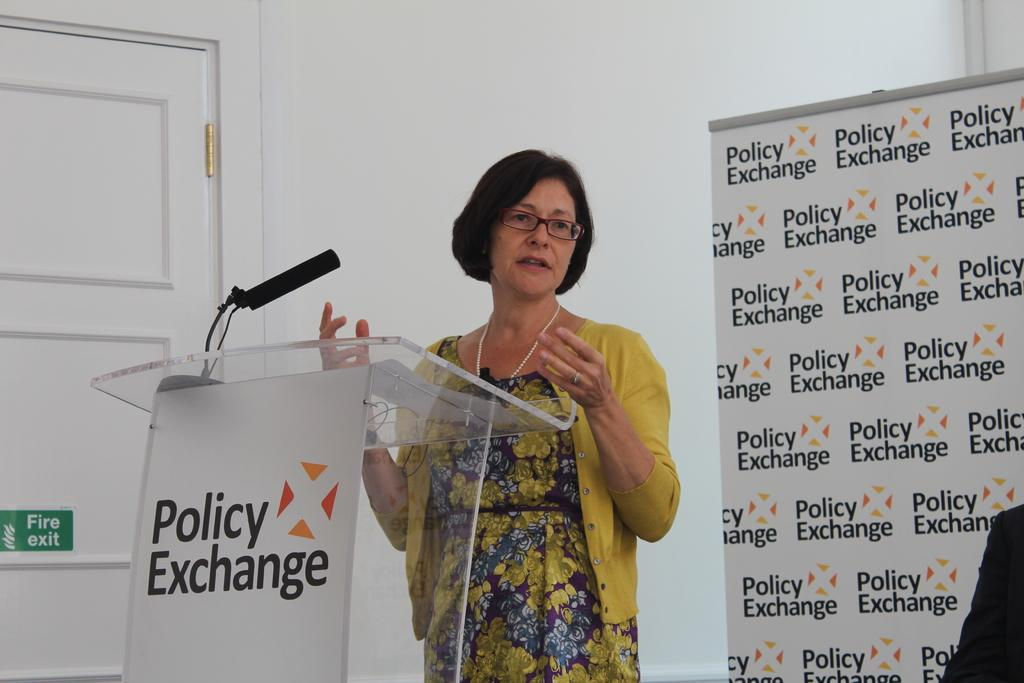What is the woman in the image doing? The woman is standing in front of a podium. What is on the podium? There is a microphone and some text on the podium. Can you describe the background of the image? There is a door, a board with text, and a wall visible in the image. How many eggs are on the wall in the image? There are no eggs present on the wall in the image. 